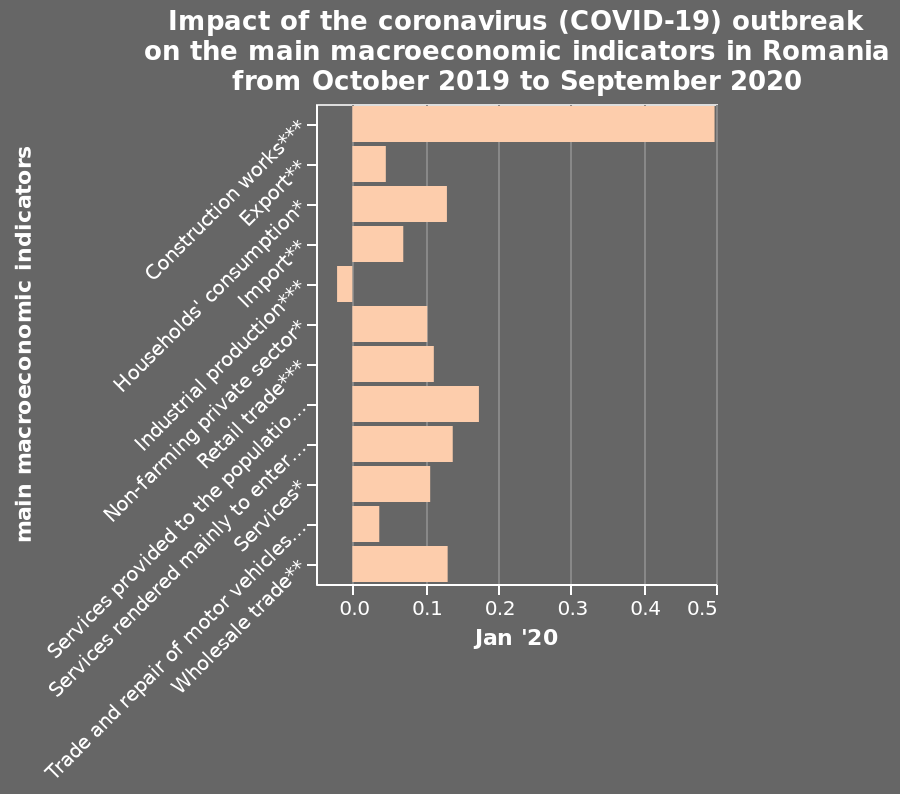<image>
What was the main effect of the coronavirus pandemic on the construction industry?  The main effect of the coronavirus pandemic was a significant impact on the construction industry. 